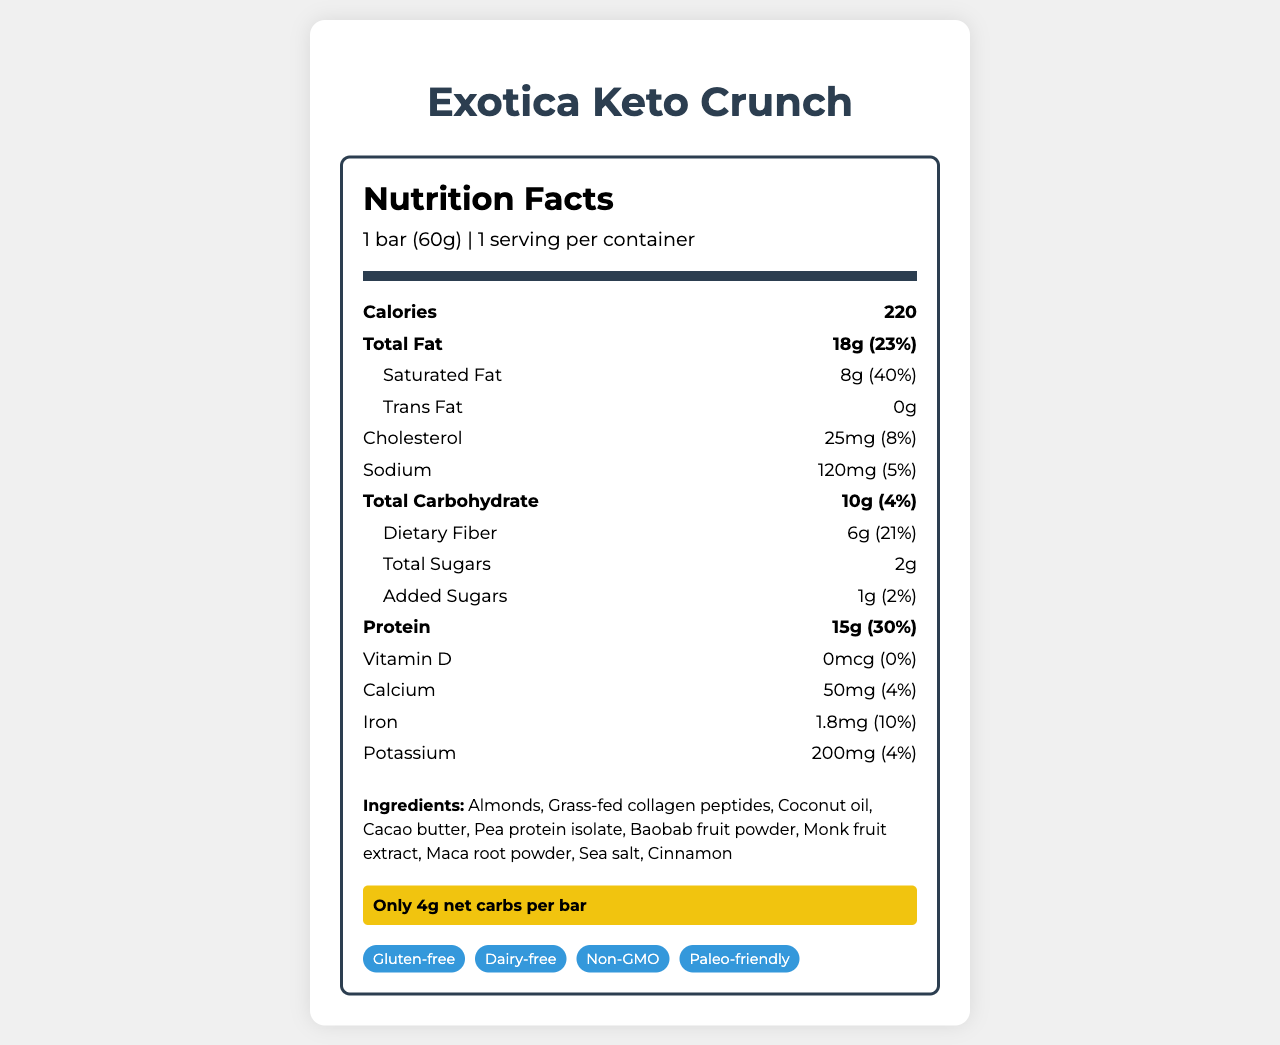What is the serving size for Exotica Keto Crunch? The serving size is clearly indicated at the beginning of the document.
Answer: 1 bar (60g) How many calories are in one serving of Exotica Keto Crunch? The document states that there are 220 calories per serving.
Answer: 220 What percentage of the daily value of saturated fat is in the Exotica Keto Crunch bar? The document specifies that the saturated fat content is 8g, which is 40% of the daily value.
Answer: 40% What is the total amount of carbohydrates in one bar? The document shows that the total carbohydrate amount is 10g.
Answer: 10g How much protein is in the Exotica Keto Crunch bar? The document lists the protein amount as 15g.
Answer: 15g What are the two main protein sources in the bar? The section "protein source" highlights that the protein comes from a blend of grass-fed collagen and pea protein.
Answer: Grass-fed collagen and pea protein Which sweetener is used in the Exotica Keto Crunch bar? A. Stevia B. Monk fruit extract C. Aspartame The document mentions that the bar is "Naturally sweetened with monk fruit extract."
Answer: B. Monk fruit extract What is the amount of dietary fiber in the Exotica Keto Crunch bar? The dietary fiber content is clearly listed as 6g in the document.
Answer: 6g Is Exotica Keto Crunch bar gluten-free? The document includes "gluten-free" under dietary considerations.
Answer: Yes Which exotic ingredients are highlighted in the Exotica Keto Crunch bar? The document specifically mentions that baobab fruit and maca root are the exotic ingredients.
Answer: Baobab fruit and maca root How many grams of added sugars are in the Exotica Keto Crunch bar? A. 0g B. 1g C. 2g The document states that the bar has 1g of added sugars.
Answer: B. 1g Does the Exotica Keto Crunch bar claim to be non-GMO? Under dietary considerations, the document lists the bar as non-GMO.
Answer: Yes What should you do if you want to learn more about the taste and texture of the bar? The document includes a snippet mentioning a full review diving into the taste and texture in the blog.
Answer: Read the full review on the blog What is the sodium content of the Exotica Keto Crunch bar? A. 100mg B. 120mg C. 150mg The document indicates that the sodium content is 120mg.
Answer: B. 120mg Does the Exotica Keto Crunch bar contain any tree nuts? The allergen info states that the bar contains tree nuts (almonds).
Answer: Yes Is the Exotica Keto Crunch bar paleo-friendly? The dietary considerations list the product as paleo-friendly.
Answer: Yes What are the storage instructions for the Exotica Keto Crunch bar? The document provides these specific storage instructions.
Answer: Store in a cool, dry place. Consume within 14 days of opening. Can the Exotica Keto Crunch bar be manufactured in a facility that processes soy? The allergen info mentions that the bar is manufactured in a facility that also processes soy.
Answer: Yes Summarize the main idea of the document. The document provides comprehensive information regarding the nutritional content, ingredients, health claims, and storage instructions of the Exotica Keto Crunch bar, emphasizing its suitability for various dietary needs and its unique flavor profile.
Answer: The document provides detailed nutrition facts, ingredients, dietary considerations, and other key information about the Exotica Keto Crunch bar. It highlights that the bar is keto-friendly, gluten-free, dairy-free, non-GMO, paleo-friendly, and contains exotic ingredients like baobab fruit and maca root. The allergen and storage information are also provided, along with a teaser for a full review on the blog. Does the Exotica Keto Crunch bar contain vitamin C? The document does not provide any details about the vitamin C content.
Answer: Not enough information 